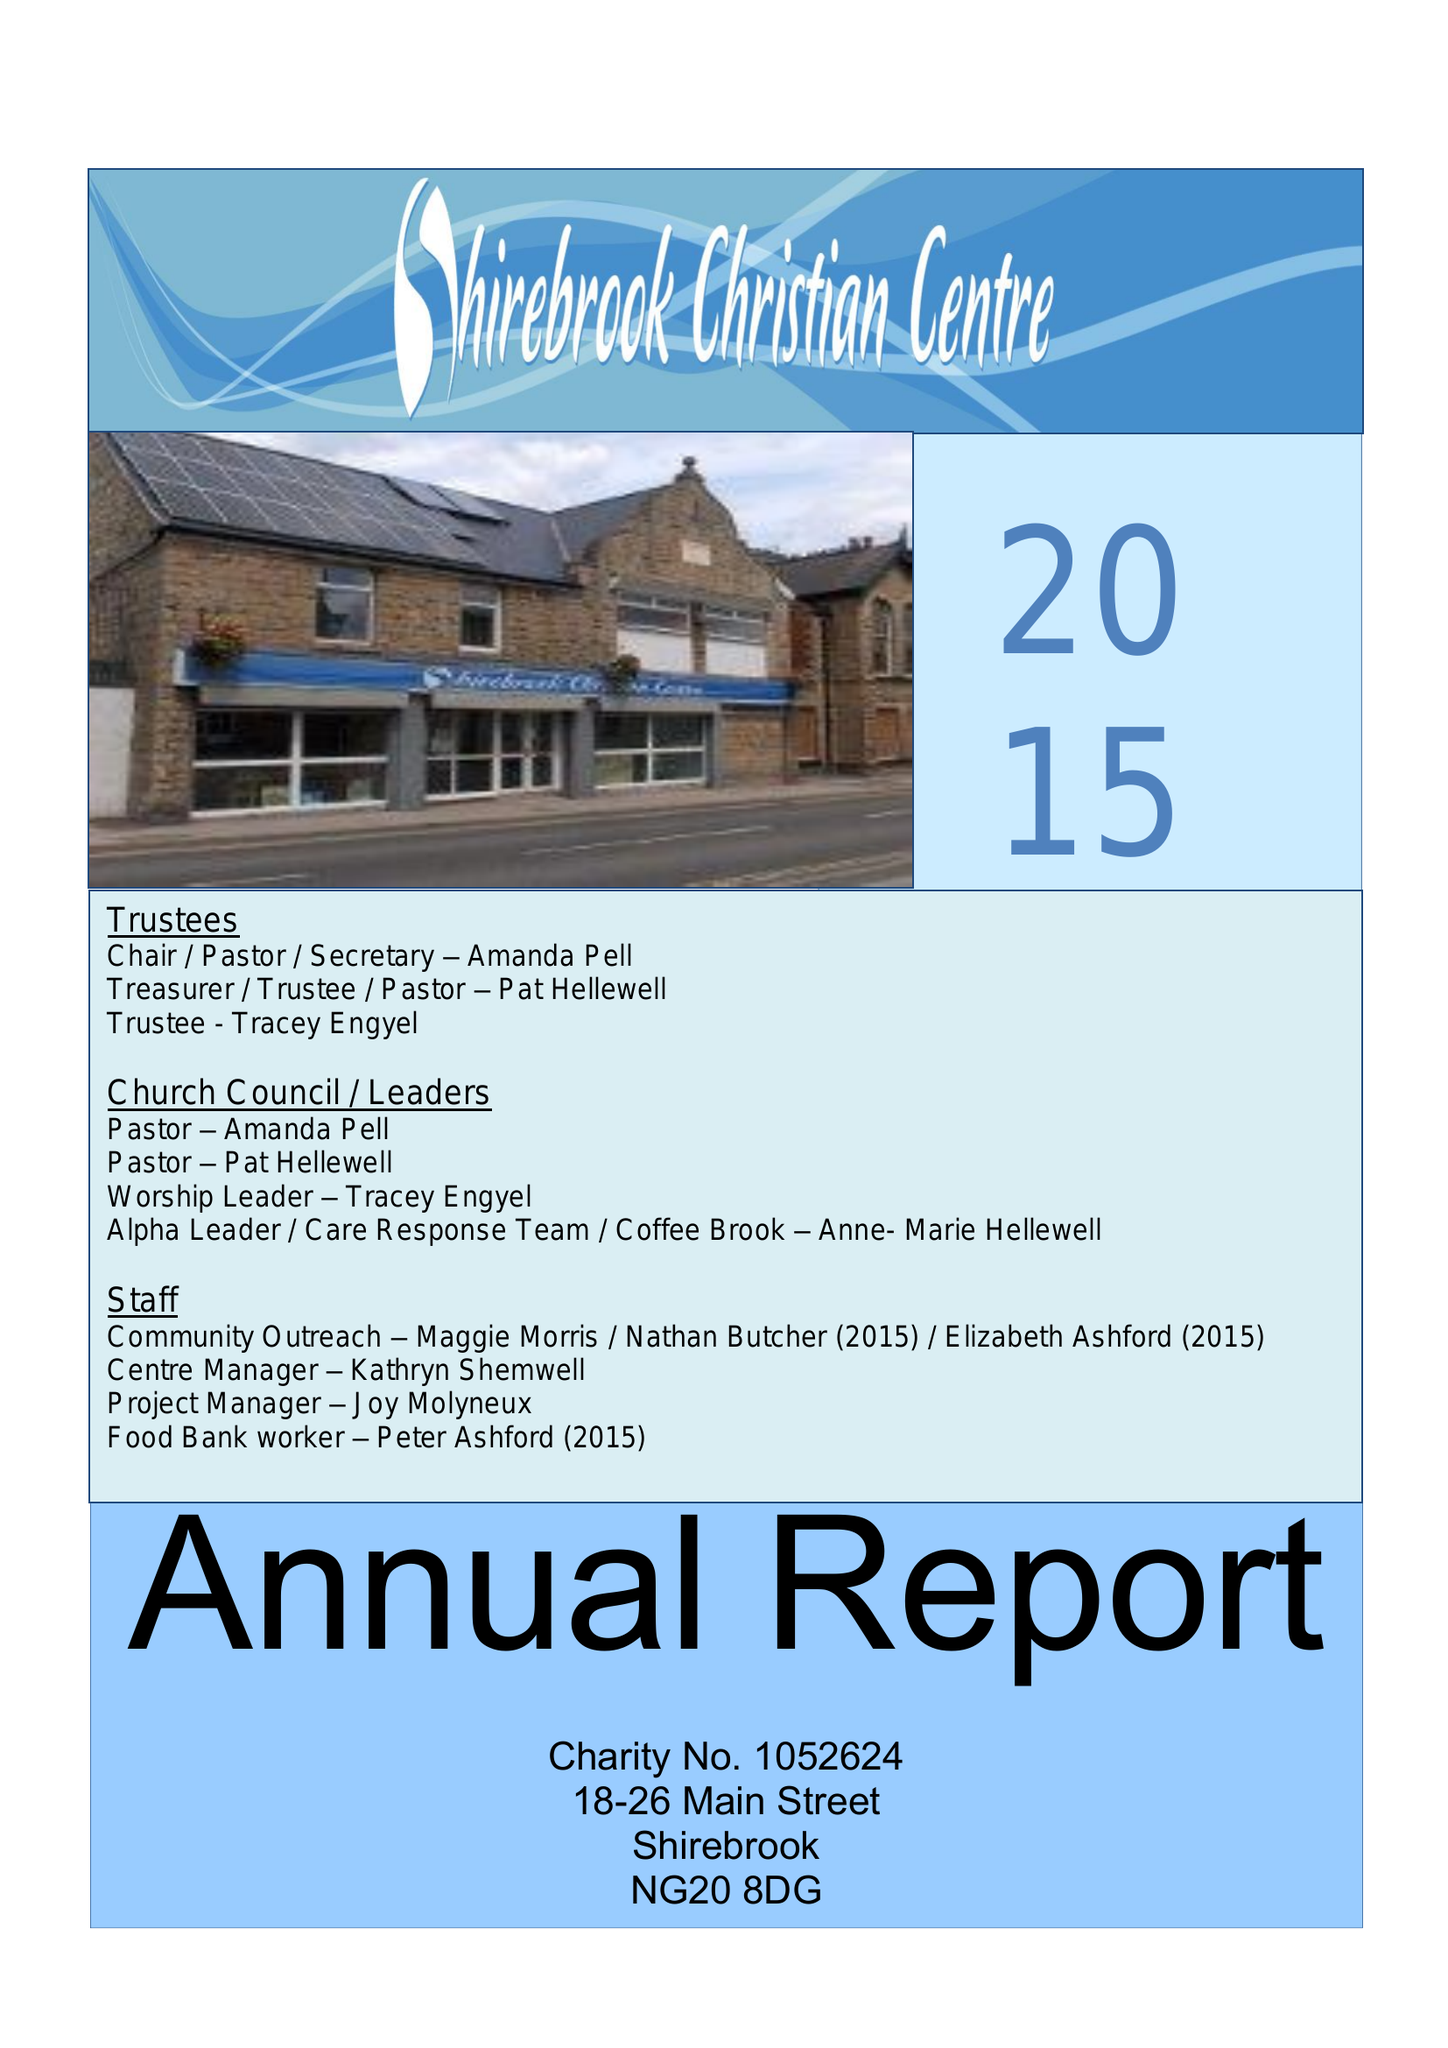What is the value for the address__post_town?
Answer the question using a single word or phrase. MANSFIELD 